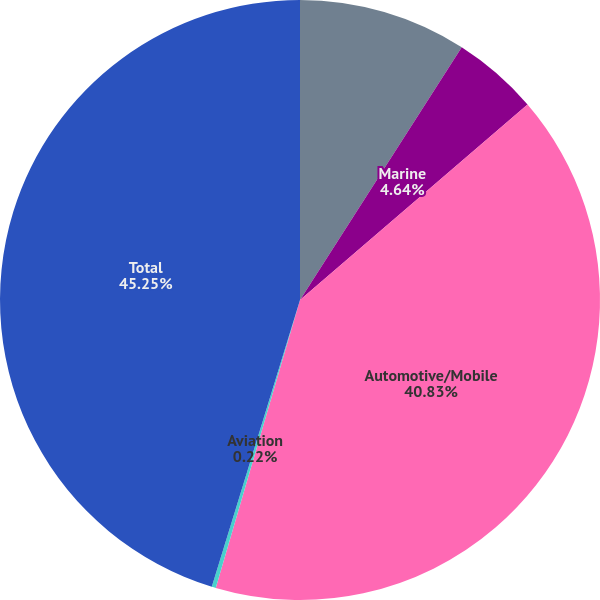Convert chart to OTSL. <chart><loc_0><loc_0><loc_500><loc_500><pie_chart><fcel>Outdoor/Fitness<fcel>Marine<fcel>Automotive/Mobile<fcel>Aviation<fcel>Total<nl><fcel>9.06%<fcel>4.64%<fcel>40.82%<fcel>0.22%<fcel>45.24%<nl></chart> 